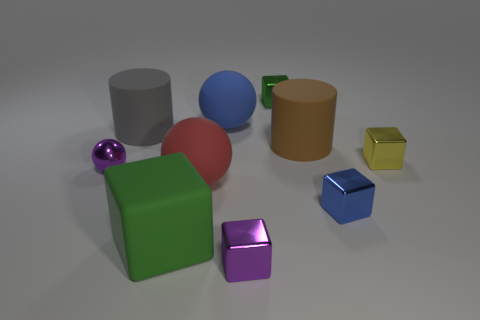Subtract all purple blocks. How many blocks are left? 4 Subtract all large green blocks. How many blocks are left? 4 Subtract all cyan cylinders. Subtract all gray blocks. How many cylinders are left? 2 Subtract all cylinders. How many objects are left? 8 Subtract 1 blue blocks. How many objects are left? 9 Subtract all blue shiny blocks. Subtract all small blocks. How many objects are left? 5 Add 3 small spheres. How many small spheres are left? 4 Add 7 tiny shiny spheres. How many tiny shiny spheres exist? 8 